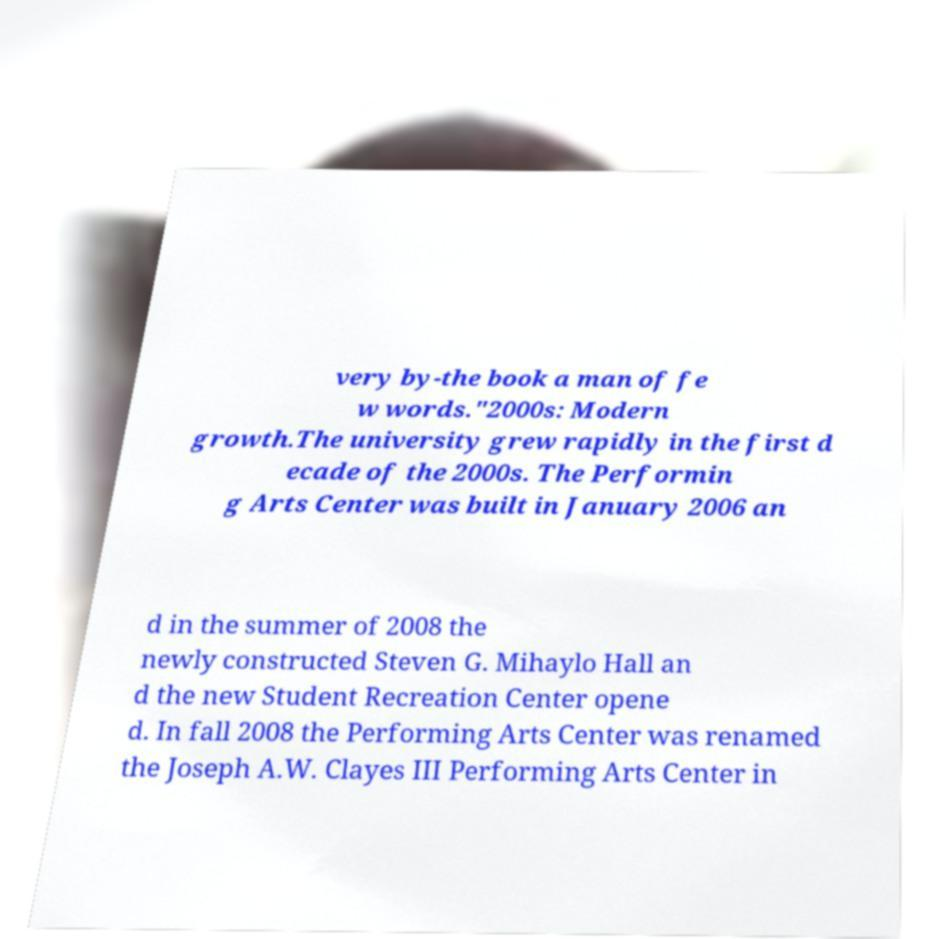There's text embedded in this image that I need extracted. Can you transcribe it verbatim? very by-the book a man of fe w words."2000s: Modern growth.The university grew rapidly in the first d ecade of the 2000s. The Performin g Arts Center was built in January 2006 an d in the summer of 2008 the newly constructed Steven G. Mihaylo Hall an d the new Student Recreation Center opene d. In fall 2008 the Performing Arts Center was renamed the Joseph A.W. Clayes III Performing Arts Center in 